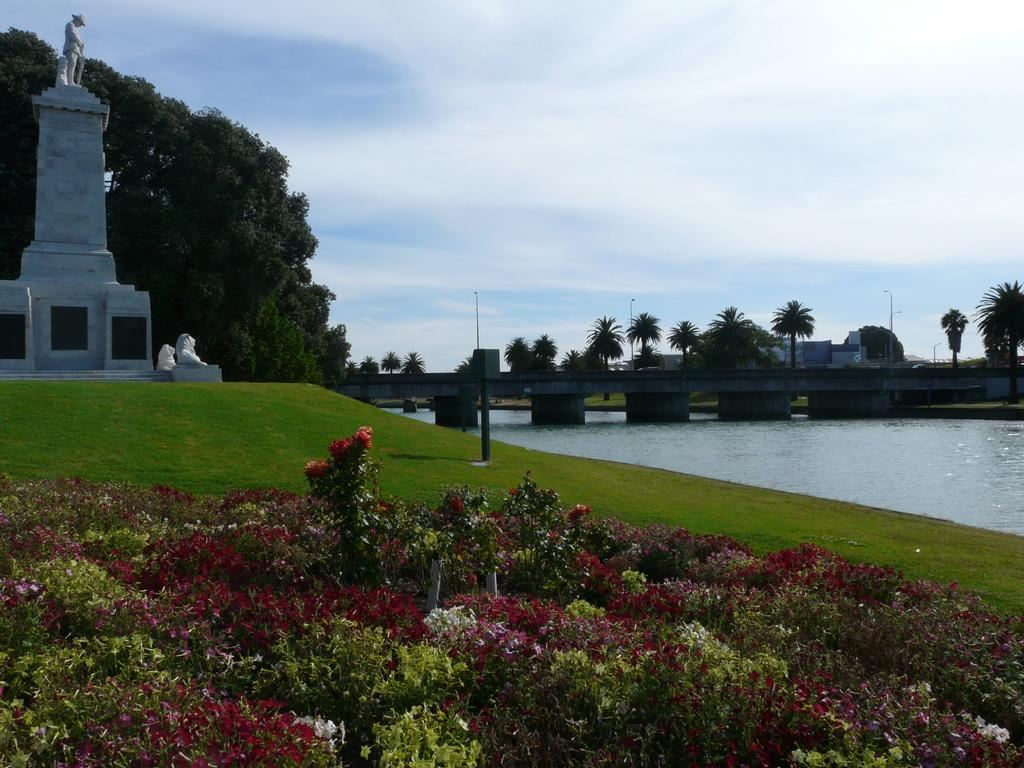What is the main feature in the center of the image? There is water in the center of the image. What type of vegetation can be seen in the image? There is grass, plants, and trees present in the image. What other natural elements are visible in the image? Flowers are visible in the image. Are there any man-made structures in the image? Yes, there are statues, buildings, and poles in the image. What type of architectural feature can be seen in the image? There is a bridge in the image. What can be seen in the background of the image? The sky is visible in the background of the image, with clouds present. What type of grape is being used as a hobby in the image? There is no grape or hobby present in the image. What type of structure is being built by the statue in the image? There is no statue building any structure in the image. 